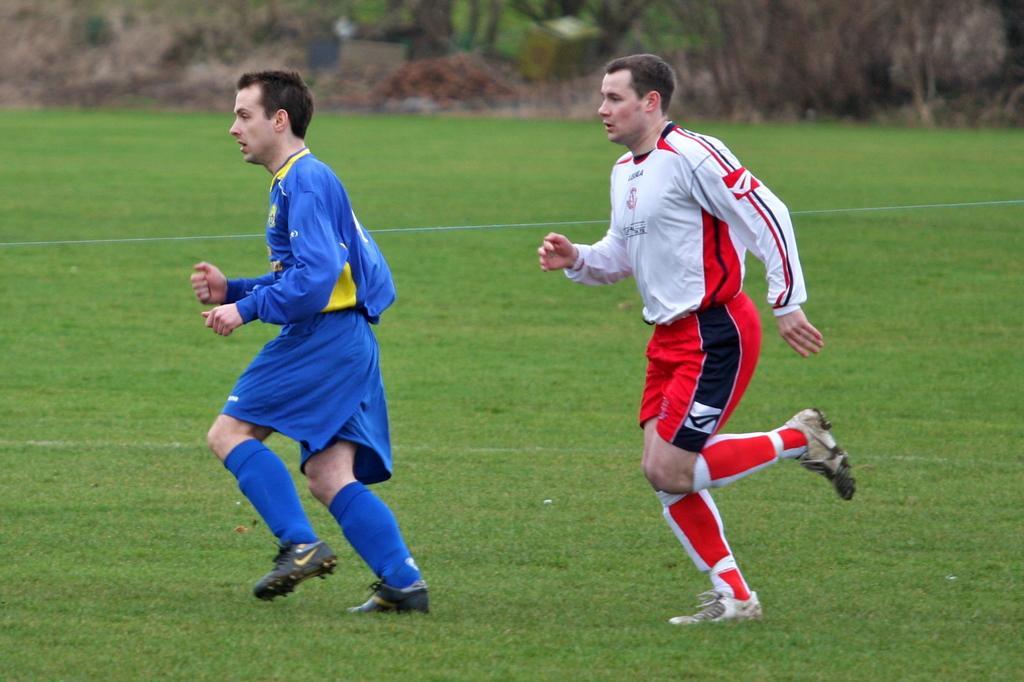How would you summarize this image in a sentence or two? In this image, we can see two men are running on the grass. In the background, there is a blur view. At the top of the image, we can see plants and few objects. 